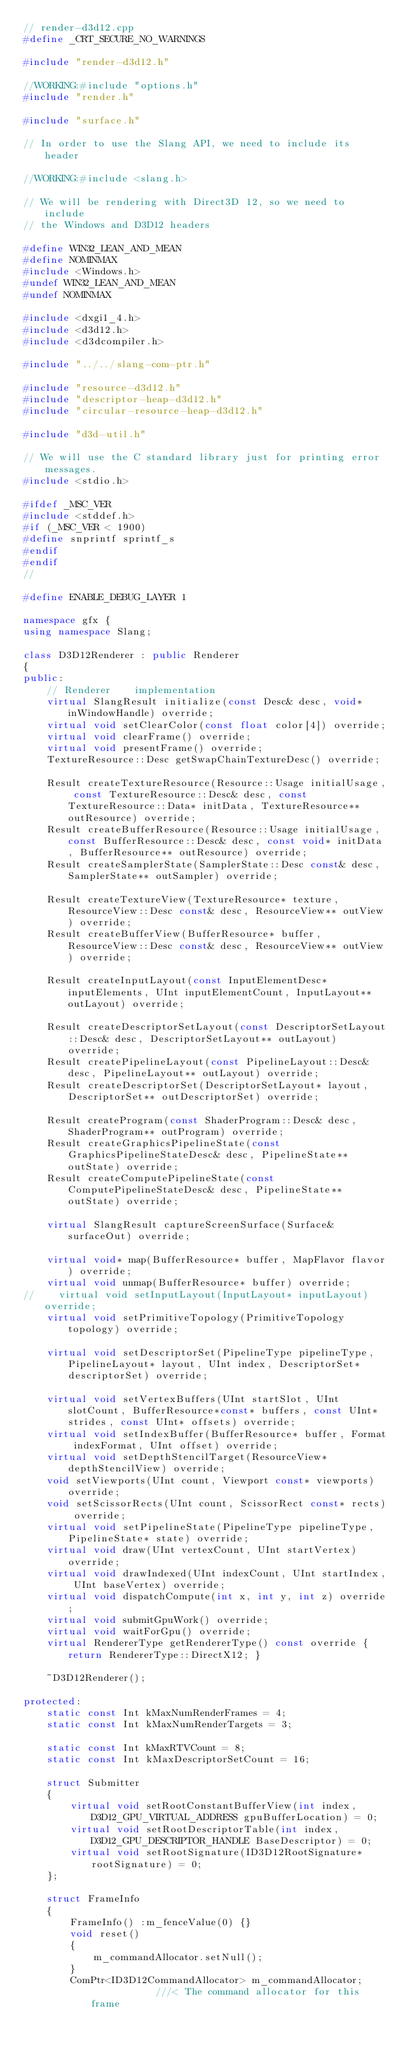<code> <loc_0><loc_0><loc_500><loc_500><_C++_>// render-d3d12.cpp
#define _CRT_SECURE_NO_WARNINGS

#include "render-d3d12.h"

//WORKING:#include "options.h"
#include "render.h"

#include "surface.h"

// In order to use the Slang API, we need to include its header

//WORKING:#include <slang.h>

// We will be rendering with Direct3D 12, so we need to include
// the Windows and D3D12 headers

#define WIN32_LEAN_AND_MEAN
#define NOMINMAX
#include <Windows.h>
#undef WIN32_LEAN_AND_MEAN
#undef NOMINMAX

#include <dxgi1_4.h>
#include <d3d12.h>
#include <d3dcompiler.h>

#include "../../slang-com-ptr.h"

#include "resource-d3d12.h"
#include "descriptor-heap-d3d12.h"
#include "circular-resource-heap-d3d12.h"

#include "d3d-util.h"

// We will use the C standard library just for printing error messages.
#include <stdio.h>

#ifdef _MSC_VER
#include <stddef.h>
#if (_MSC_VER < 1900)
#define snprintf sprintf_s
#endif
#endif
//

#define ENABLE_DEBUG_LAYER 1

namespace gfx {
using namespace Slang;

class D3D12Renderer : public Renderer
{
public:
    // Renderer    implementation
    virtual SlangResult initialize(const Desc& desc, void* inWindowHandle) override;
    virtual void setClearColor(const float color[4]) override;
    virtual void clearFrame() override;
    virtual void presentFrame() override;
    TextureResource::Desc getSwapChainTextureDesc() override;

    Result createTextureResource(Resource::Usage initialUsage, const TextureResource::Desc& desc, const TextureResource::Data* initData, TextureResource** outResource) override;
    Result createBufferResource(Resource::Usage initialUsage, const BufferResource::Desc& desc, const void* initData, BufferResource** outResource) override;
    Result createSamplerState(SamplerState::Desc const& desc, SamplerState** outSampler) override;

    Result createTextureView(TextureResource* texture, ResourceView::Desc const& desc, ResourceView** outView) override;
    Result createBufferView(BufferResource* buffer, ResourceView::Desc const& desc, ResourceView** outView) override;

    Result createInputLayout(const InputElementDesc* inputElements, UInt inputElementCount, InputLayout** outLayout) override;

    Result createDescriptorSetLayout(const DescriptorSetLayout::Desc& desc, DescriptorSetLayout** outLayout) override;
    Result createPipelineLayout(const PipelineLayout::Desc& desc, PipelineLayout** outLayout) override;
    Result createDescriptorSet(DescriptorSetLayout* layout, DescriptorSet** outDescriptorSet) override;

    Result createProgram(const ShaderProgram::Desc& desc, ShaderProgram** outProgram) override;
    Result createGraphicsPipelineState(const GraphicsPipelineStateDesc& desc, PipelineState** outState) override;
    Result createComputePipelineState(const ComputePipelineStateDesc& desc, PipelineState** outState) override;

    virtual SlangResult captureScreenSurface(Surface& surfaceOut) override;

    virtual void* map(BufferResource* buffer, MapFlavor flavor) override;
    virtual void unmap(BufferResource* buffer) override;
//    virtual void setInputLayout(InputLayout* inputLayout) override;
    virtual void setPrimitiveTopology(PrimitiveTopology topology) override;

    virtual void setDescriptorSet(PipelineType pipelineType, PipelineLayout* layout, UInt index, DescriptorSet* descriptorSet) override;

    virtual void setVertexBuffers(UInt startSlot, UInt slotCount, BufferResource*const* buffers, const UInt* strides, const UInt* offsets) override;
    virtual void setIndexBuffer(BufferResource* buffer, Format indexFormat, UInt offset) override;
    virtual void setDepthStencilTarget(ResourceView* depthStencilView) override;
    void setViewports(UInt count, Viewport const* viewports) override;
    void setScissorRects(UInt count, ScissorRect const* rects) override;
    virtual void setPipelineState(PipelineType pipelineType, PipelineState* state) override;
    virtual void draw(UInt vertexCount, UInt startVertex) override;
    virtual void drawIndexed(UInt indexCount, UInt startIndex, UInt baseVertex) override;
    virtual void dispatchCompute(int x, int y, int z) override;
    virtual void submitGpuWork() override;
    virtual void waitForGpu() override;
    virtual RendererType getRendererType() const override { return RendererType::DirectX12; }

    ~D3D12Renderer();

protected:
    static const Int kMaxNumRenderFrames = 4;
    static const Int kMaxNumRenderTargets = 3;

    static const Int kMaxRTVCount = 8;
    static const Int kMaxDescriptorSetCount = 16;

    struct Submitter
    {
        virtual void setRootConstantBufferView(int index, D3D12_GPU_VIRTUAL_ADDRESS gpuBufferLocation) = 0;
        virtual void setRootDescriptorTable(int index, D3D12_GPU_DESCRIPTOR_HANDLE BaseDescriptor) = 0;
        virtual void setRootSignature(ID3D12RootSignature* rootSignature) = 0;
    };

    struct FrameInfo
    {
        FrameInfo() :m_fenceValue(0) {}
        void reset()
        {
            m_commandAllocator.setNull();
        }
        ComPtr<ID3D12CommandAllocator> m_commandAllocator;            ///< The command allocator for this frame</code> 